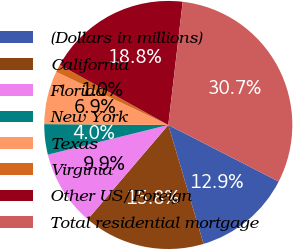<chart> <loc_0><loc_0><loc_500><loc_500><pie_chart><fcel>(Dollars in millions)<fcel>California<fcel>Florida<fcel>New York<fcel>Texas<fcel>Virginia<fcel>Other US/Foreign<fcel>Total residential mortgage<nl><fcel>12.87%<fcel>15.84%<fcel>9.9%<fcel>3.96%<fcel>6.93%<fcel>1.0%<fcel>18.81%<fcel>30.68%<nl></chart> 